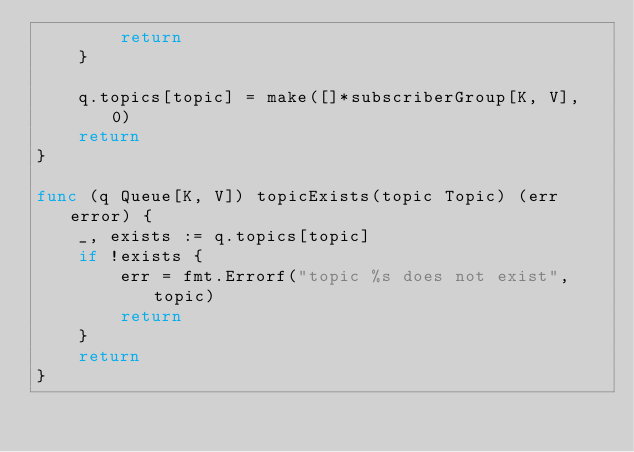Convert code to text. <code><loc_0><loc_0><loc_500><loc_500><_Go_>		return
	}

	q.topics[topic] = make([]*subscriberGroup[K, V], 0)
	return
}

func (q Queue[K, V]) topicExists(topic Topic) (err error) {
	_, exists := q.topics[topic]
	if !exists {
		err = fmt.Errorf("topic %s does not exist", topic)
		return
	}
	return 
}
</code> 